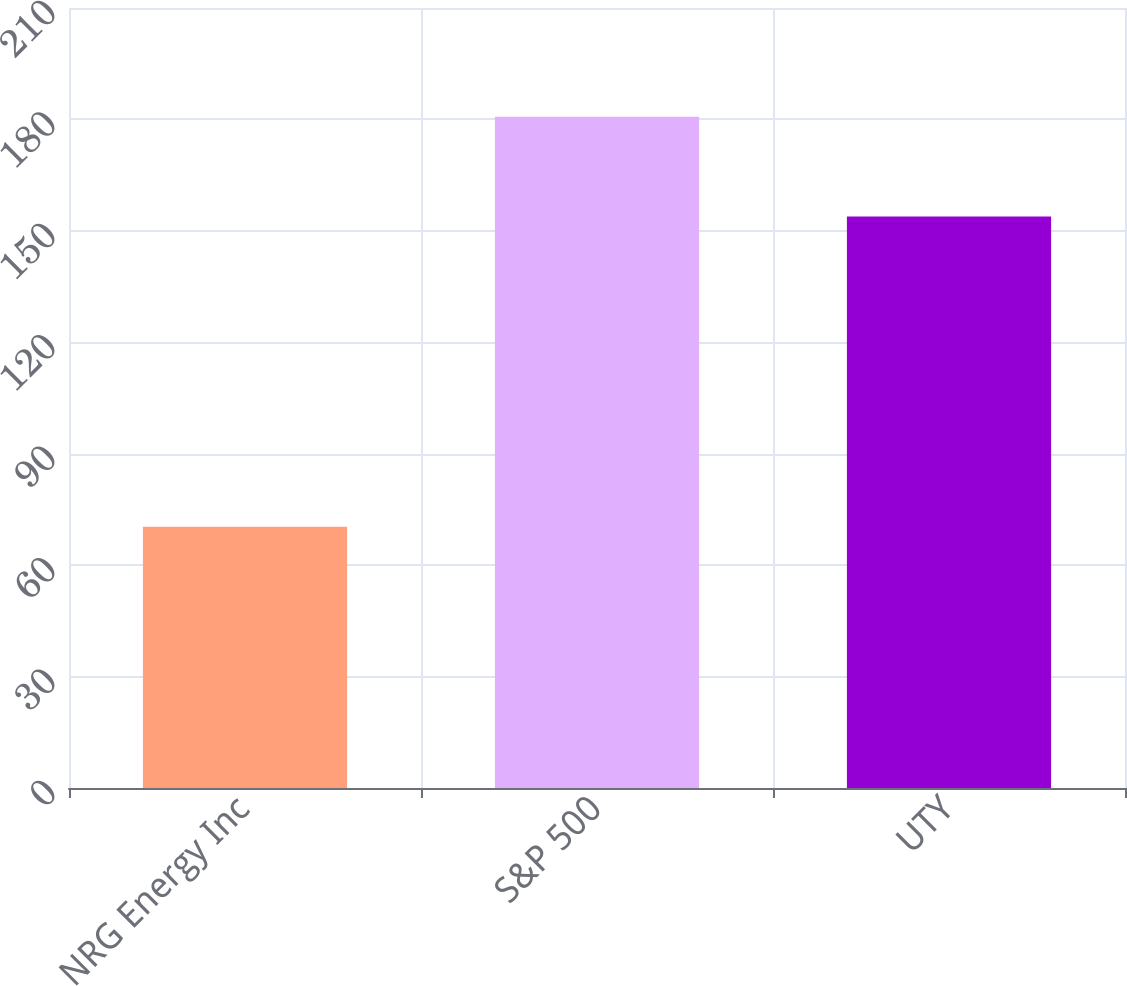Convert chart. <chart><loc_0><loc_0><loc_500><loc_500><bar_chart><fcel>NRG Energy Inc<fcel>S&P 500<fcel>UTY<nl><fcel>70.37<fcel>180.75<fcel>153.85<nl></chart> 